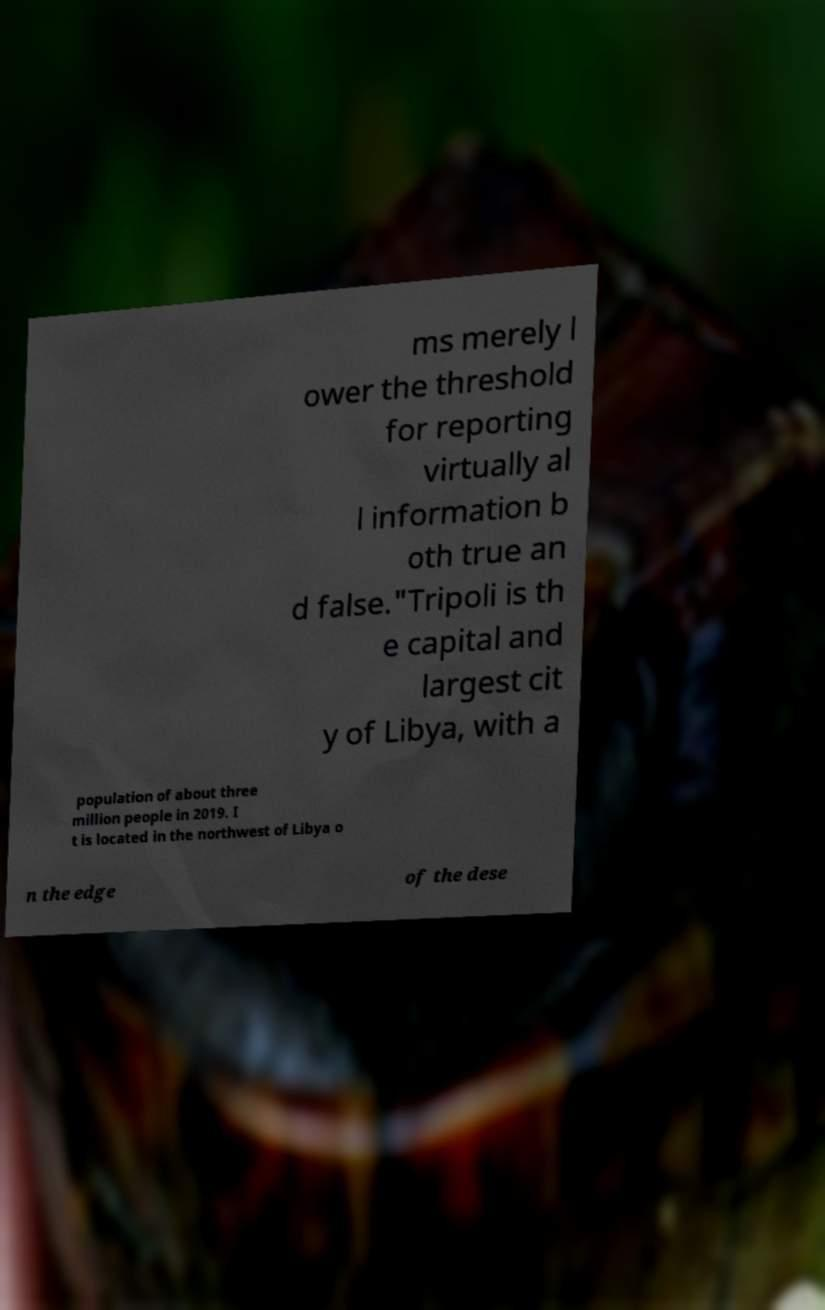Please identify and transcribe the text found in this image. ms merely l ower the threshold for reporting virtually al l information b oth true an d false."Tripoli is th e capital and largest cit y of Libya, with a population of about three million people in 2019. I t is located in the northwest of Libya o n the edge of the dese 